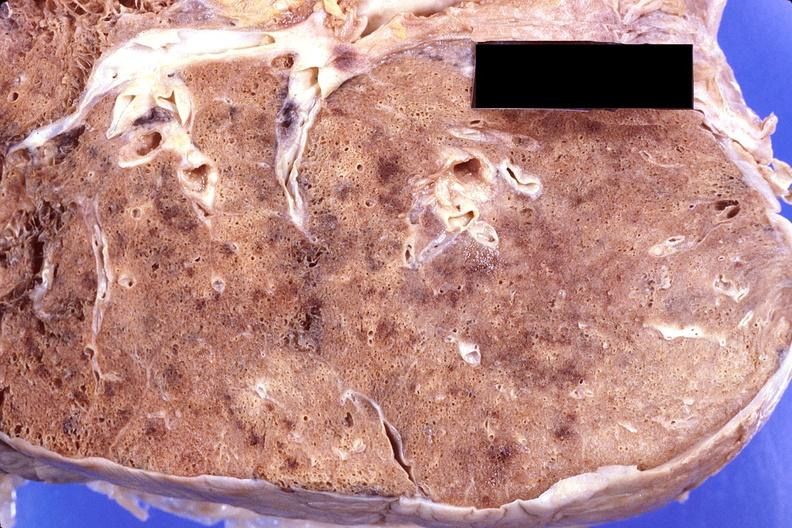where is this?
Answer the question using a single word or phrase. Lung 